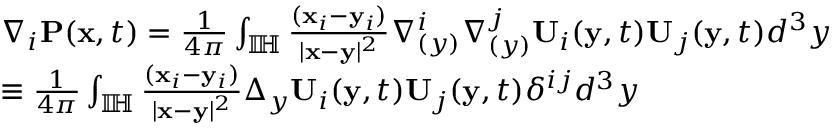<formula> <loc_0><loc_0><loc_500><loc_500>\begin{array} { r l } & { \nabla _ { i } P ( x , t ) = \frac { 1 } { 4 \pi } \int _ { \mathbb { I \, H } } \frac { ( x _ { i } - y _ { i } ) } { | x - y | ^ { 2 } } \nabla _ { ( y ) } ^ { i } \nabla _ { ( y ) } ^ { j } { U } _ { i } ( y , t ) { U } _ { j } ( y , t ) d ^ { 3 } y } \\ & { \equiv \frac { 1 } { 4 \pi } \int _ { \mathbb { I \, H } } \frac { ( x _ { i } - y _ { i } ) } { | x - y | ^ { 2 } } \Delta _ { y } U _ { i } ( y , t ) U _ { j } ( y , t ) \delta ^ { i j } d ^ { 3 } y } \\ \end{array}</formula> 